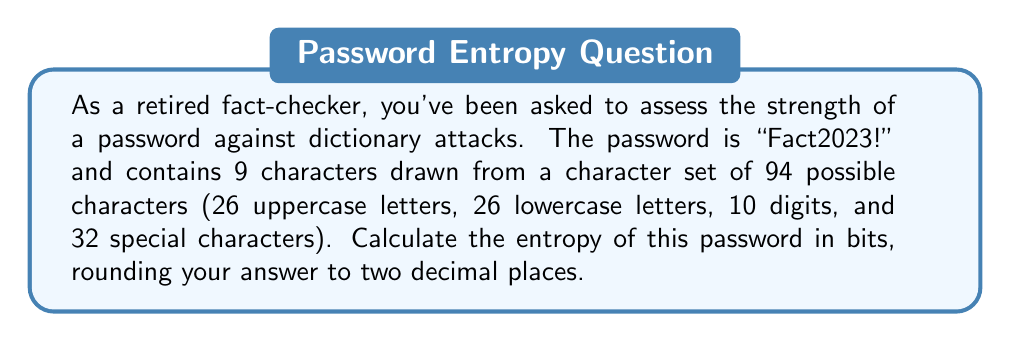Could you help me with this problem? To calculate the entropy of a password, we use the formula:

$$E = L \times \log_2(R)$$

Where:
$E$ = Entropy in bits
$L$ = Length of the password
$R$ = Size of the character set

Step 1: Identify the values
$L = 9$ (the password "Fact2023!" has 9 characters)
$R = 94$ (as stated in the question)

Step 2: Apply the formula
$$E = 9 \times \log_2(94)$$

Step 3: Calculate $\log_2(94)$
$$\log_2(94) \approx 6.5546$$

Step 4: Multiply by the length
$$E = 9 \times 6.5546 \approx 58.9914$$

Step 5: Round to two decimal places
$$E \approx 58.99\text{ bits}$$

This entropy value indicates the password's resistance to brute-force and dictionary attacks. Higher entropy generally means a stronger password.
Answer: 58.99 bits 